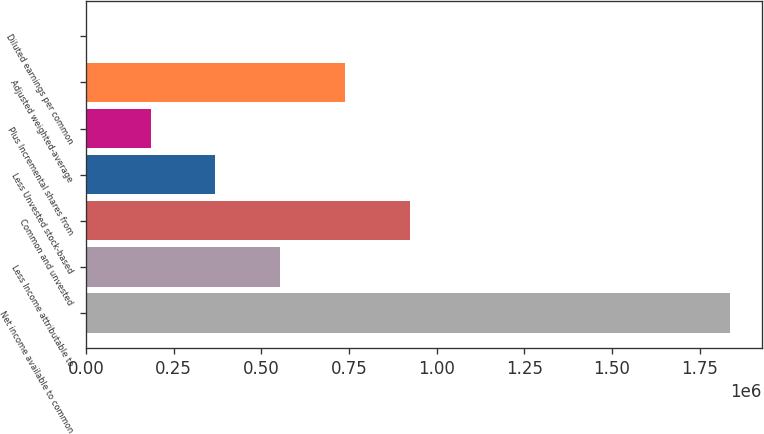Convert chart to OTSL. <chart><loc_0><loc_0><loc_500><loc_500><bar_chart><fcel>Net income available to common<fcel>Less Income attributable to<fcel>Common and unvested<fcel>Less Unvested stock-based<fcel>Plus Incremental shares from<fcel>Adjusted weighted-average<fcel>Diluted earnings per common<nl><fcel>1.83604e+06<fcel>553677<fcel>922786<fcel>369122<fcel>184567<fcel>738231<fcel>12.74<nl></chart> 